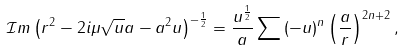Convert formula to latex. <formula><loc_0><loc_0><loc_500><loc_500>\mathcal { I } m \left ( r ^ { 2 } - 2 i \mu \sqrt { u } a - a ^ { 2 } u \right ) ^ { - \frac { 1 } { 2 } } = \frac { u ^ { \frac { 1 } { 2 } } } { a } \sum \left ( - u \right ) ^ { n } \left ( \frac { a } { r } \right ) ^ { 2 n + 2 } ,</formula> 